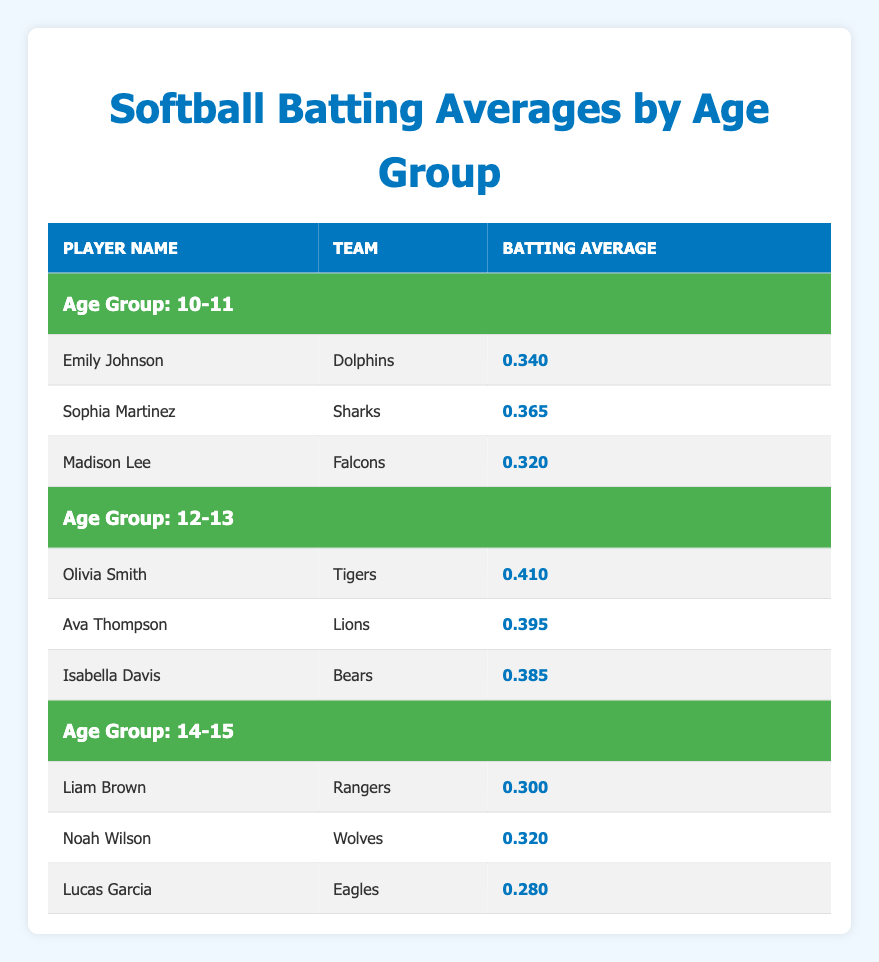What is the batting average of Sophia Martinez? Sophia Martinez is listed in the "10-11" age group with a batting average of 0.365.
Answer: 0.365 Which player has the highest batting average in the 12-13 age group? According to the table, Olivia Smith has the highest batting average of 0.410 in the "12-13" age group.
Answer: Olivia Smith Is there a player in the 14-15 age group with a batting average above 0.300? Looking at the "14-15" age group, both Liam Brown (0.300) and Noah Wilson (0.320) have averages that meet this criterion. Thus, yes, there are players above 0.300.
Answer: Yes What is the average batting average for the players in the 10-11 age group? To find the average, we add the batting averages: 0.340 + 0.365 + 0.320 = 1.025. Then we divide by the number of players (3): 1.025/3 = 0.3417. Rounding to three decimal places gives 0.342.
Answer: 0.342 How many players in total are listed in the table? We count the players across all age groups: 3 in "10-11", 3 in "12-13", and 3 in "14-15". Thus, 3 + 3 + 3 = 9 players in total.
Answer: 9 Is Liam Brown the only player in the 14-15 age group with a batting average below 0.300? Looking at the 14-15 age group, Liam Brown (0.300), Noah Wilson (0.320), and Lucas Garcia (0.280) are present. Since Lucas Garcia has a batting average below 0.300, the statement is false.
Answer: No What is the difference in batting averages between the highest and lowest players in the 12-13 age group? The highest batting average is Olivia Smith (0.410) and the lowest is Isabella Davis (0.385). The difference is calculated as 0.410 - 0.385 = 0.025.
Answer: 0.025 Which age group has the lowest average batting average? The averages are: "10-11": (0.340 + 0.365 + 0.320)/3 = 0.342, "12-13": (0.410 + 0.395 + 0.385)/3 = 0.3967, and "14-15": (0.300 + 0.320 + 0.280)/3 = 0.300. The lowest average is in the 14-15 age group.
Answer: 14-15 Are there more players from the Sharks team or the Lions team? In the table, only Sophia Martinez represents the Sharks, while Ava Thompson represents the Lions. Therefore, there is one player from each team, resulting in a tie.
Answer: Tie 